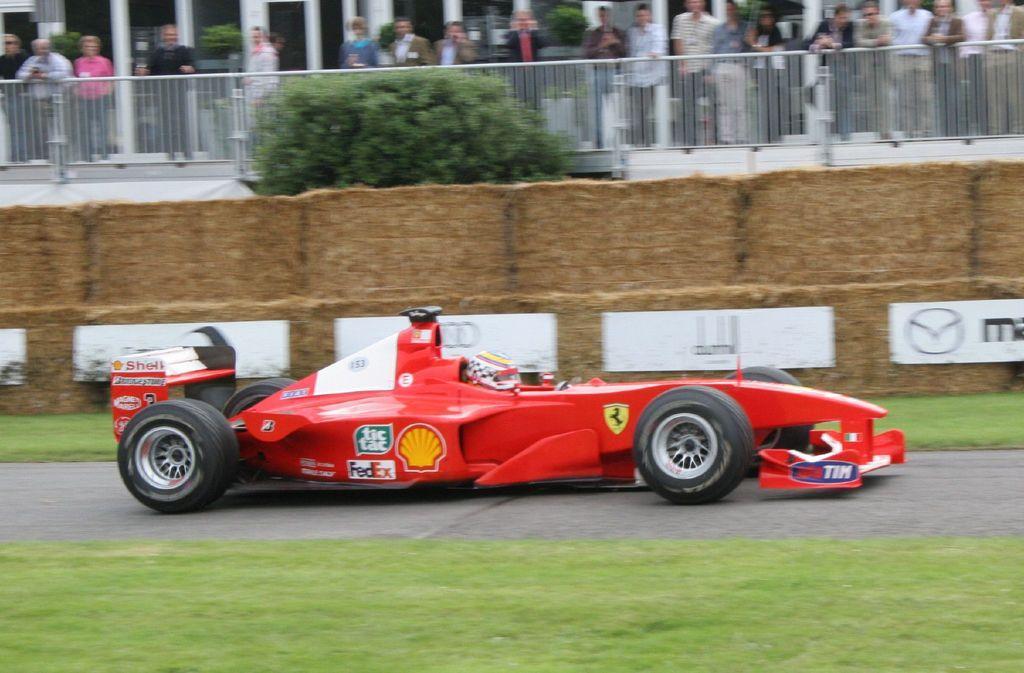Describe this image in one or two sentences. In this image I can see a car which is red, white and black in color on the road. I can see some grass. In the background I can see the wall, few trees, the railing and few persons standing on the other side of the railing. 